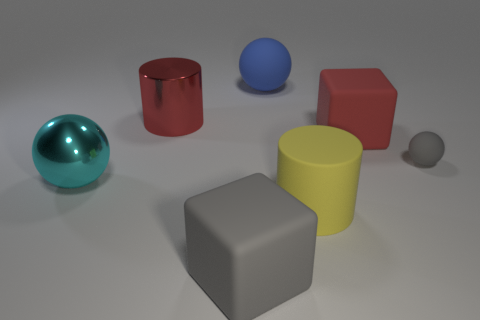Are there any red metal objects to the left of the metal thing to the left of the metallic thing behind the big cyan ball?
Your answer should be very brief. No. There is a rubber thing that is on the left side of the yellow matte thing and in front of the tiny gray ball; what is its size?
Keep it short and to the point. Large. How many blue cylinders have the same material as the small object?
Your answer should be compact. 0. How many blocks are large purple rubber things or shiny objects?
Your response must be concise. 0. There is a matte thing behind the large shiny object on the right side of the large shiny object in front of the small sphere; how big is it?
Provide a short and direct response. Large. The ball that is on the right side of the large gray cube and to the left of the small object is what color?
Offer a very short reply. Blue. There is a metal ball; is it the same size as the metal object behind the tiny object?
Keep it short and to the point. Yes. Is there anything else that has the same shape as the large red rubber object?
Offer a very short reply. Yes. The small object that is the same shape as the big cyan thing is what color?
Offer a very short reply. Gray. Do the blue ball and the yellow matte object have the same size?
Provide a succinct answer. Yes. 